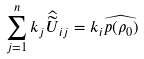Convert formula to latex. <formula><loc_0><loc_0><loc_500><loc_500>\sum _ { j = 1 } ^ { n } k _ { j } \widehat { \widetilde { U } } _ { i j } = k _ { i } \widehat { p ( \rho _ { 0 } ) }</formula> 